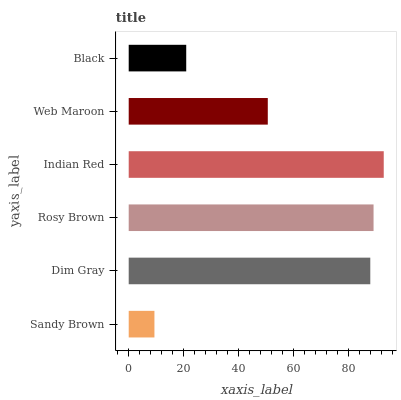Is Sandy Brown the minimum?
Answer yes or no. Yes. Is Indian Red the maximum?
Answer yes or no. Yes. Is Dim Gray the minimum?
Answer yes or no. No. Is Dim Gray the maximum?
Answer yes or no. No. Is Dim Gray greater than Sandy Brown?
Answer yes or no. Yes. Is Sandy Brown less than Dim Gray?
Answer yes or no. Yes. Is Sandy Brown greater than Dim Gray?
Answer yes or no. No. Is Dim Gray less than Sandy Brown?
Answer yes or no. No. Is Dim Gray the high median?
Answer yes or no. Yes. Is Web Maroon the low median?
Answer yes or no. Yes. Is Indian Red the high median?
Answer yes or no. No. Is Black the low median?
Answer yes or no. No. 